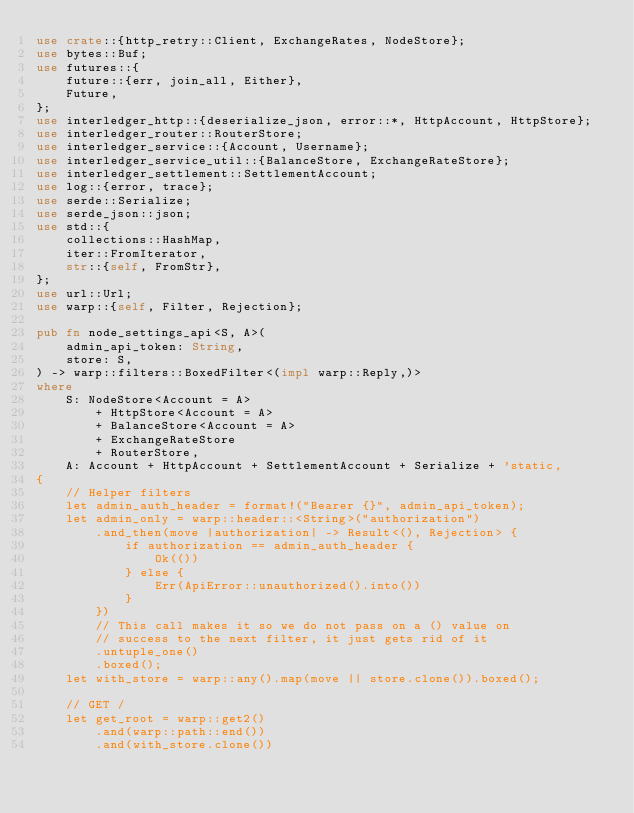Convert code to text. <code><loc_0><loc_0><loc_500><loc_500><_Rust_>use crate::{http_retry::Client, ExchangeRates, NodeStore};
use bytes::Buf;
use futures::{
    future::{err, join_all, Either},
    Future,
};
use interledger_http::{deserialize_json, error::*, HttpAccount, HttpStore};
use interledger_router::RouterStore;
use interledger_service::{Account, Username};
use interledger_service_util::{BalanceStore, ExchangeRateStore};
use interledger_settlement::SettlementAccount;
use log::{error, trace};
use serde::Serialize;
use serde_json::json;
use std::{
    collections::HashMap,
    iter::FromIterator,
    str::{self, FromStr},
};
use url::Url;
use warp::{self, Filter, Rejection};

pub fn node_settings_api<S, A>(
    admin_api_token: String,
    store: S,
) -> warp::filters::BoxedFilter<(impl warp::Reply,)>
where
    S: NodeStore<Account = A>
        + HttpStore<Account = A>
        + BalanceStore<Account = A>
        + ExchangeRateStore
        + RouterStore,
    A: Account + HttpAccount + SettlementAccount + Serialize + 'static,
{
    // Helper filters
    let admin_auth_header = format!("Bearer {}", admin_api_token);
    let admin_only = warp::header::<String>("authorization")
        .and_then(move |authorization| -> Result<(), Rejection> {
            if authorization == admin_auth_header {
                Ok(())
            } else {
                Err(ApiError::unauthorized().into())
            }
        })
        // This call makes it so we do not pass on a () value on
        // success to the next filter, it just gets rid of it
        .untuple_one()
        .boxed();
    let with_store = warp::any().map(move || store.clone()).boxed();

    // GET /
    let get_root = warp::get2()
        .and(warp::path::end())
        .and(with_store.clone())</code> 